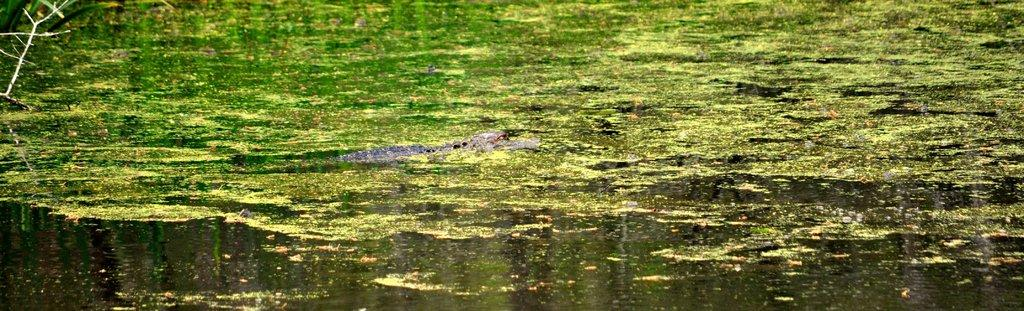What animal is present in the image? There is a crocodile in the image. What color is the crocodile? The crocodile is in black color. What can be seen on the water in the image? There is an object in green color on the water. What level of decision-making is required for the furniture in the image? There is no furniture present in the image, so the question of decision-making level is not applicable. 